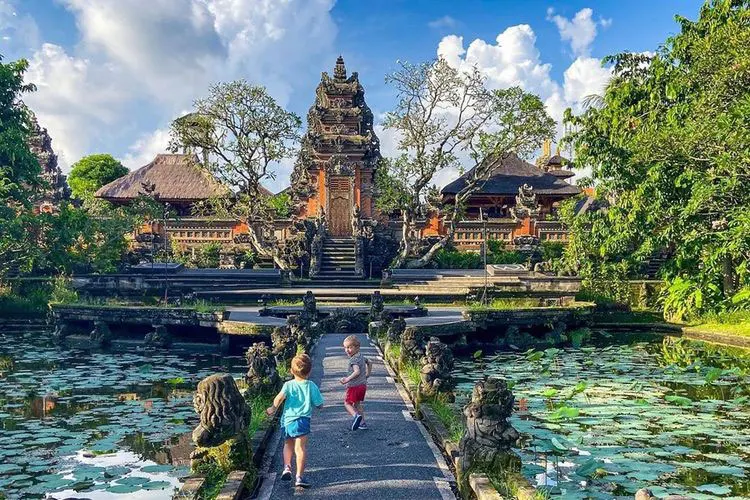How does this palace function in the everyday life of locals? The Ubud Water Palace is a central cultural hub for the local community. It serves multiple functions including being a tourist attraction that brings economic benefits to the area. Locally, it is a place of worship and spiritual gatherings during festivals and religious ceremonies, reflecting its importance in Balinese Hindu traditions. Additionally, the palace's open spaces and scenic beauty make it a popular spot for communal and recreational activities among locals, linking it to both cultural preservation and contemporary community life. 